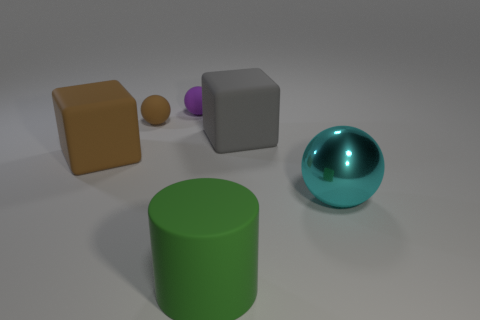Is there anything else that has the same material as the big cyan sphere?
Your response must be concise. No. What material is the large cube that is to the right of the big thing that is on the left side of the large green cylinder made of?
Make the answer very short. Rubber. Is there a matte object that has the same color as the big matte cylinder?
Your answer should be very brief. No. There is a brown cube that is made of the same material as the gray cube; what is its size?
Provide a succinct answer. Large. Is there anything else that is the same color as the cylinder?
Offer a very short reply. No. There is a big cube in front of the gray object; what is its color?
Your answer should be very brief. Brown. Is there a big brown object that is to the right of the large matte object that is on the right side of the matte object in front of the cyan sphere?
Offer a very short reply. No. Are there more tiny brown matte spheres that are right of the purple sphere than big gray rubber cubes?
Ensure brevity in your answer.  No. Is the shape of the rubber object that is in front of the cyan metallic thing the same as  the small brown matte object?
Your answer should be compact. No. What number of objects are either big gray shiny cylinders or large things in front of the big metallic object?
Provide a succinct answer. 1. 